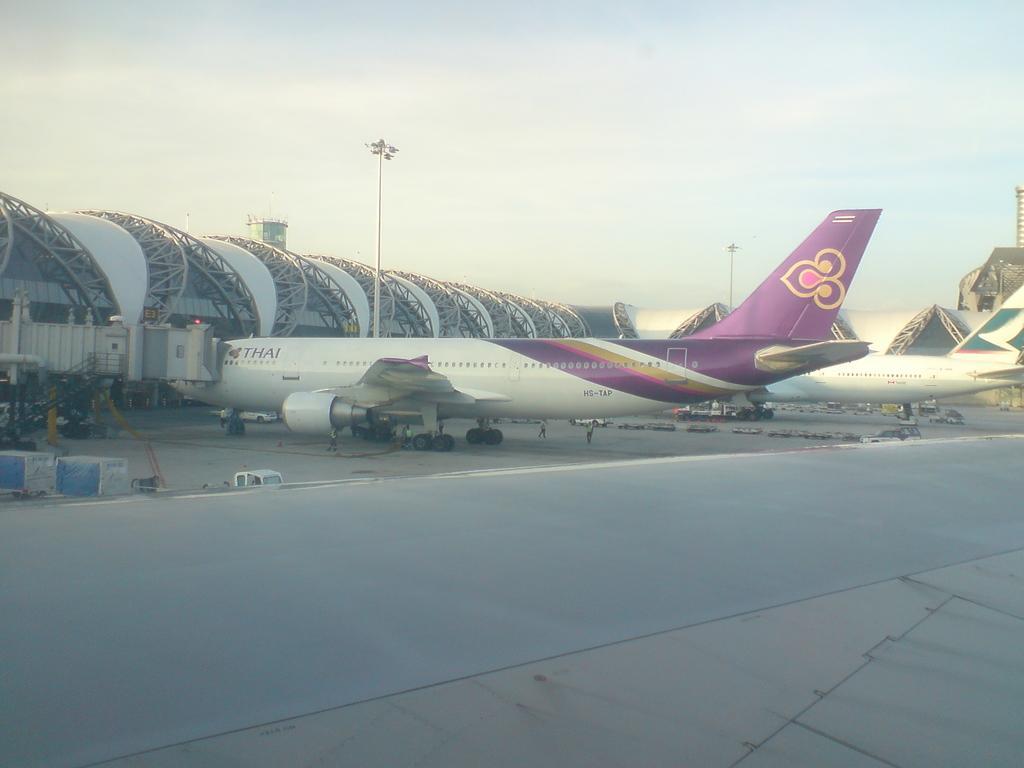In one or two sentences, can you explain what this image depicts? In this picture we can see airplanes on the ground and we can see sky in the background. 